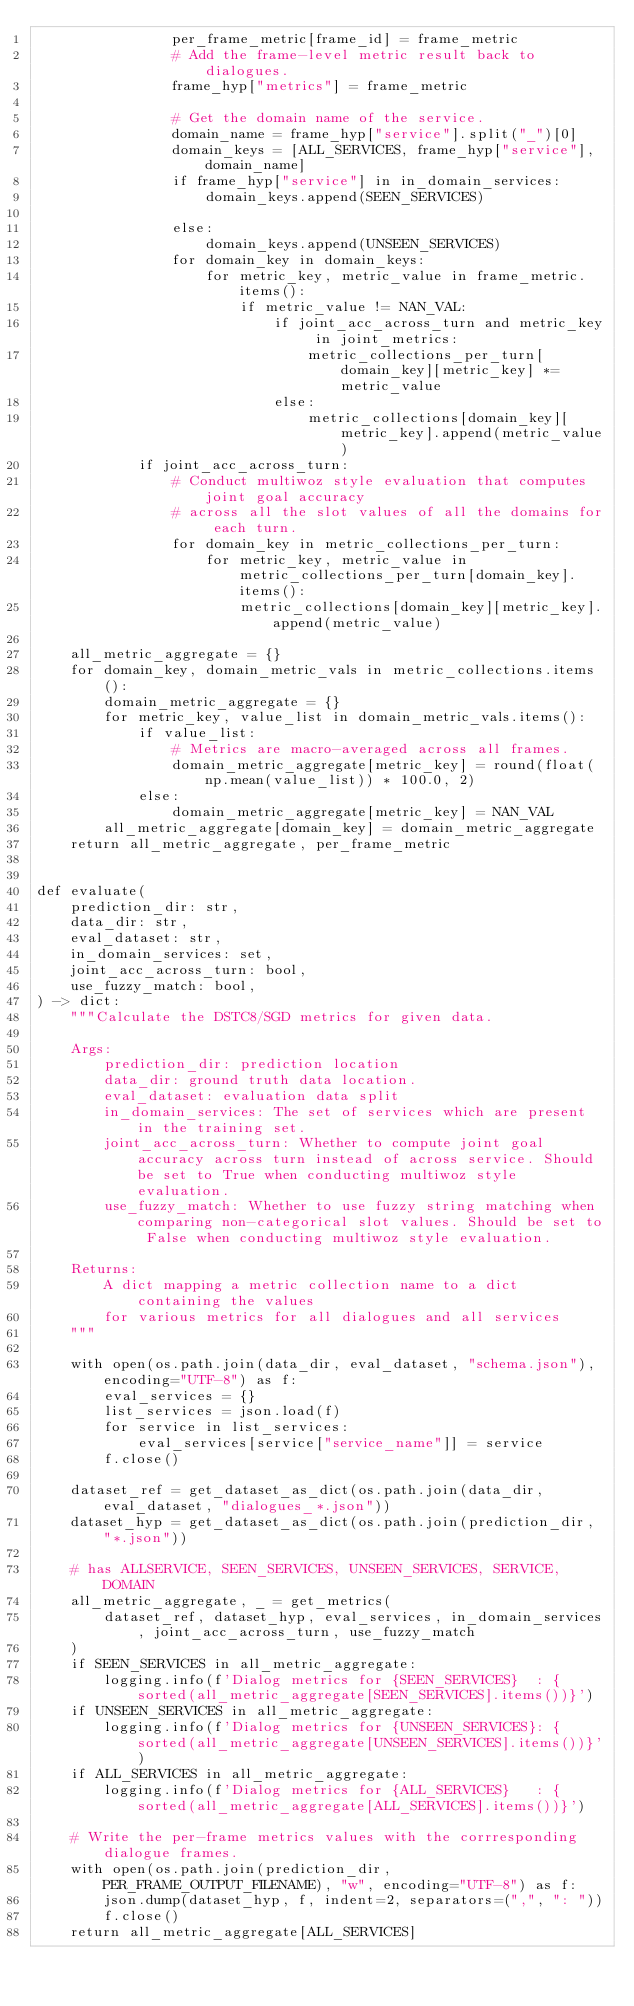Convert code to text. <code><loc_0><loc_0><loc_500><loc_500><_Python_>                per_frame_metric[frame_id] = frame_metric
                # Add the frame-level metric result back to dialogues.
                frame_hyp["metrics"] = frame_metric

                # Get the domain name of the service.
                domain_name = frame_hyp["service"].split("_")[0]
                domain_keys = [ALL_SERVICES, frame_hyp["service"], domain_name]
                if frame_hyp["service"] in in_domain_services:
                    domain_keys.append(SEEN_SERVICES)

                else:
                    domain_keys.append(UNSEEN_SERVICES)
                for domain_key in domain_keys:
                    for metric_key, metric_value in frame_metric.items():
                        if metric_value != NAN_VAL:
                            if joint_acc_across_turn and metric_key in joint_metrics:
                                metric_collections_per_turn[domain_key][metric_key] *= metric_value
                            else:
                                metric_collections[domain_key][metric_key].append(metric_value)
            if joint_acc_across_turn:
                # Conduct multiwoz style evaluation that computes joint goal accuracy
                # across all the slot values of all the domains for each turn.
                for domain_key in metric_collections_per_turn:
                    for metric_key, metric_value in metric_collections_per_turn[domain_key].items():
                        metric_collections[domain_key][metric_key].append(metric_value)

    all_metric_aggregate = {}
    for domain_key, domain_metric_vals in metric_collections.items():
        domain_metric_aggregate = {}
        for metric_key, value_list in domain_metric_vals.items():
            if value_list:
                # Metrics are macro-averaged across all frames.
                domain_metric_aggregate[metric_key] = round(float(np.mean(value_list)) * 100.0, 2)
            else:
                domain_metric_aggregate[metric_key] = NAN_VAL
        all_metric_aggregate[domain_key] = domain_metric_aggregate
    return all_metric_aggregate, per_frame_metric


def evaluate(
    prediction_dir: str,
    data_dir: str,
    eval_dataset: str,
    in_domain_services: set,
    joint_acc_across_turn: bool,
    use_fuzzy_match: bool,
) -> dict:
    """Calculate the DSTC8/SGD metrics for given data.

    Args:
        prediction_dir: prediction location
        data_dir: ground truth data location.
        eval_dataset: evaluation data split
        in_domain_services: The set of services which are present in the training set.
        joint_acc_across_turn: Whether to compute joint goal accuracy across turn instead of across service. Should be set to True when conducting multiwoz style evaluation.
        use_fuzzy_match: Whether to use fuzzy string matching when comparing non-categorical slot values. Should be set to False when conducting multiwoz style evaluation.

    Returns:
        A dict mapping a metric collection name to a dict containing the values
        for various metrics for all dialogues and all services
    """

    with open(os.path.join(data_dir, eval_dataset, "schema.json"), encoding="UTF-8") as f:
        eval_services = {}
        list_services = json.load(f)
        for service in list_services:
            eval_services[service["service_name"]] = service
        f.close()

    dataset_ref = get_dataset_as_dict(os.path.join(data_dir, eval_dataset, "dialogues_*.json"))
    dataset_hyp = get_dataset_as_dict(os.path.join(prediction_dir, "*.json"))

    # has ALLSERVICE, SEEN_SERVICES, UNSEEN_SERVICES, SERVICE, DOMAIN
    all_metric_aggregate, _ = get_metrics(
        dataset_ref, dataset_hyp, eval_services, in_domain_services, joint_acc_across_turn, use_fuzzy_match
    )
    if SEEN_SERVICES in all_metric_aggregate:
        logging.info(f'Dialog metrics for {SEEN_SERVICES}  : {sorted(all_metric_aggregate[SEEN_SERVICES].items())}')
    if UNSEEN_SERVICES in all_metric_aggregate:
        logging.info(f'Dialog metrics for {UNSEEN_SERVICES}: {sorted(all_metric_aggregate[UNSEEN_SERVICES].items())}')
    if ALL_SERVICES in all_metric_aggregate:
        logging.info(f'Dialog metrics for {ALL_SERVICES}   : {sorted(all_metric_aggregate[ALL_SERVICES].items())}')

    # Write the per-frame metrics values with the corrresponding dialogue frames.
    with open(os.path.join(prediction_dir, PER_FRAME_OUTPUT_FILENAME), "w", encoding="UTF-8") as f:
        json.dump(dataset_hyp, f, indent=2, separators=(",", ": "))
        f.close()
    return all_metric_aggregate[ALL_SERVICES]
</code> 